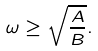Convert formula to latex. <formula><loc_0><loc_0><loc_500><loc_500>\omega \geq \sqrt { \frac { A } { B } } .</formula> 